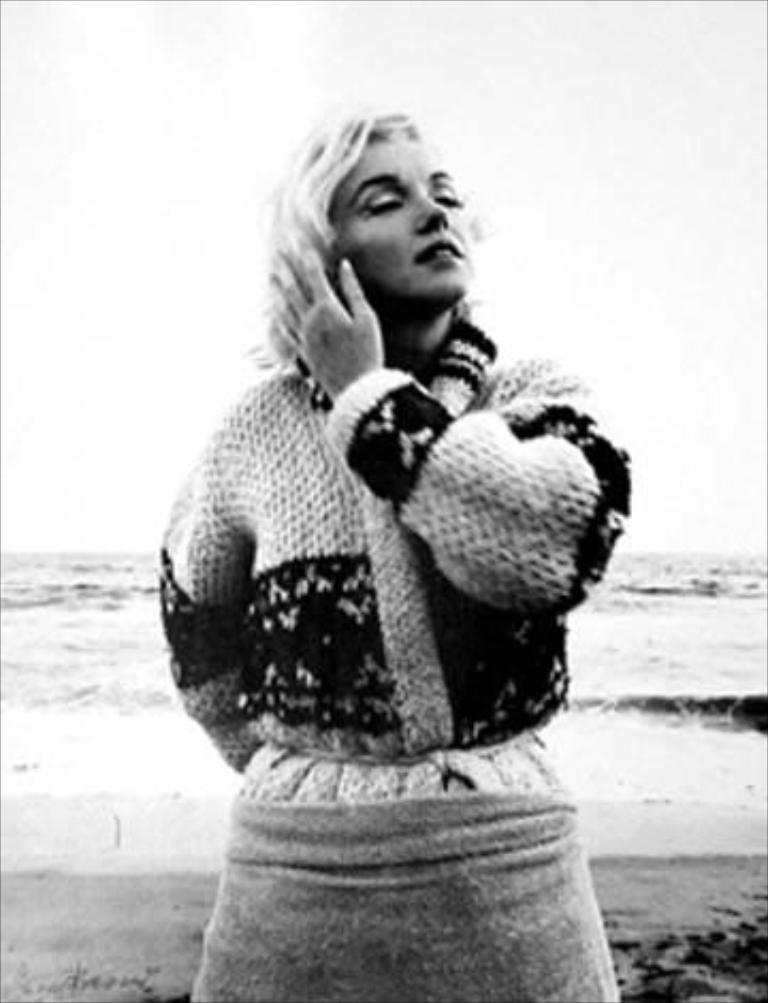What is the main subject of the image? There is a woman standing in the image. Where is the woman located in the image? The woman is in the middle of the image. What can be seen behind the woman in the image? There is water visible behind the woman. What type of bulb is hanging above the woman in the image? There is no bulb present in the image; it only features a woman standing and water visible behind her. 